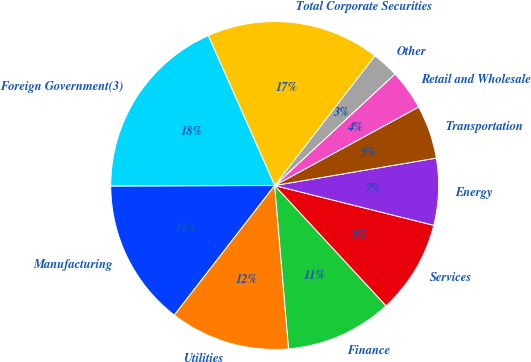Convert chart to OTSL. <chart><loc_0><loc_0><loc_500><loc_500><pie_chart><fcel>Manufacturing<fcel>Utilities<fcel>Finance<fcel>Services<fcel>Energy<fcel>Transportation<fcel>Retail and Wholesale<fcel>Other<fcel>Total Corporate Securities<fcel>Foreign Government(3)<nl><fcel>14.47%<fcel>11.84%<fcel>10.53%<fcel>9.21%<fcel>6.58%<fcel>5.27%<fcel>3.95%<fcel>2.64%<fcel>17.1%<fcel>18.41%<nl></chart> 